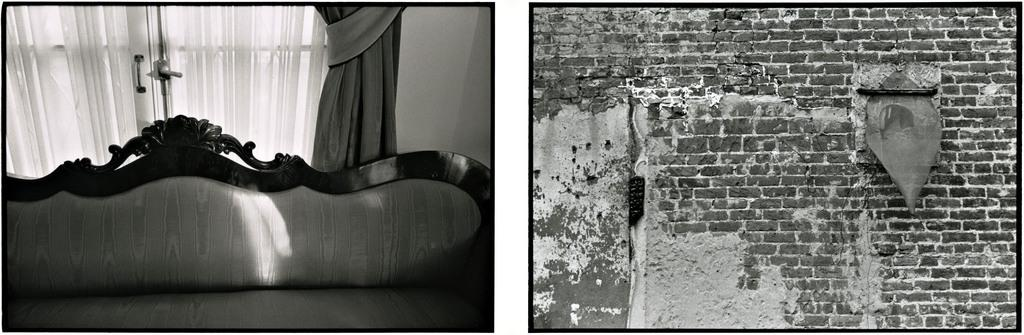What type of furniture is present in the first image? There is a sofa in the first image. What can be used to cover or block light in the first image? There is a curtain in the first image. What allows access to another room or area in the first image? There is a door in the first image. What provides a barrier or separation between spaces in the first image? There is a wall in the first image. What is present in the second image? There is a wall in the second image. How many straws are being used by the dogs in the image? There are no dogs or straws present in the image. What type of space is depicted in the image? The image does not depict a space; it shows a sofa, curtain, door, and walls. 